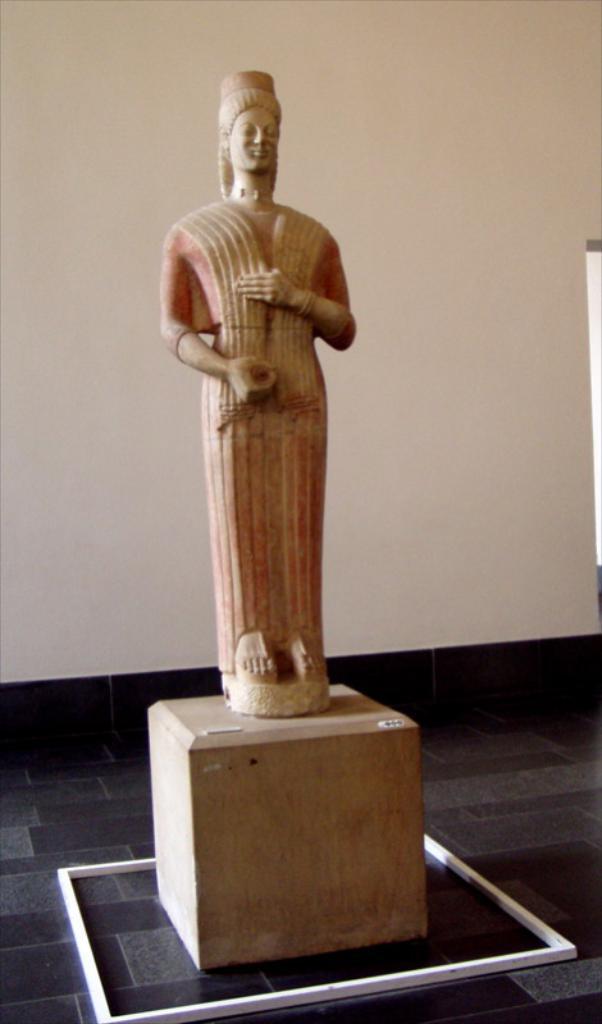Could you give a brief overview of what you see in this image? In the center of the image there is a statue. At the bottom there is a pedestal. In the background there is a wall. 